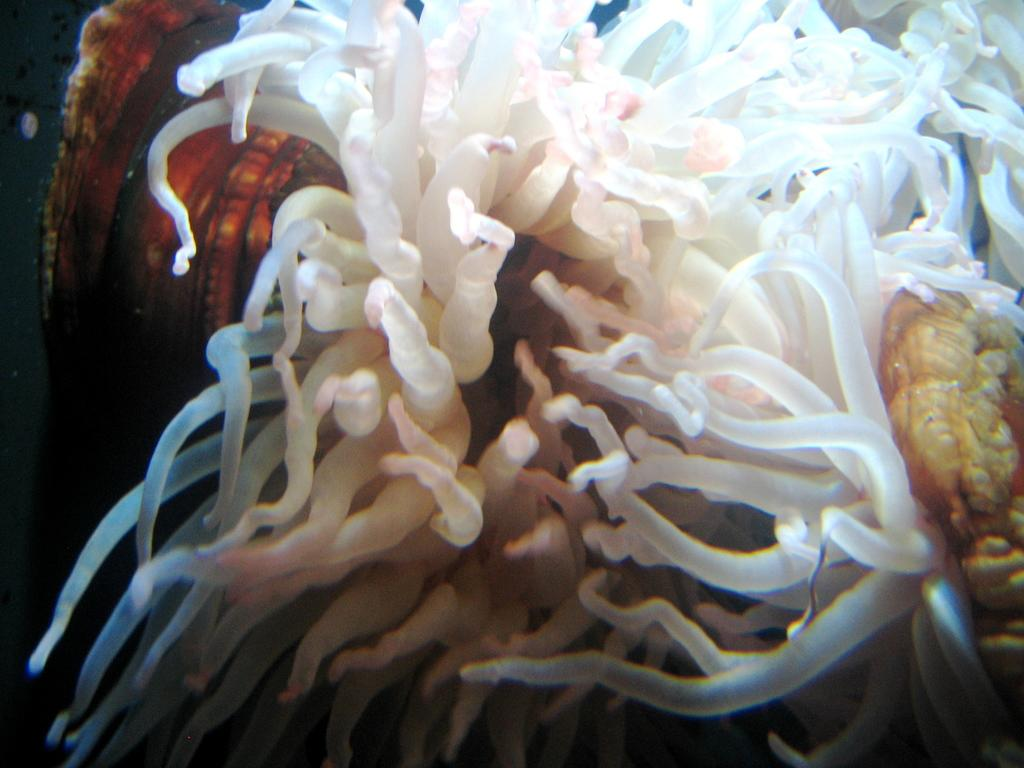What type of plants can be seen in the image? There are underwater plants in the image. Can you describe the environment in which the plants are located? The plants are located underwater. What might be the purpose of these underwater plants? The underwater plants may provide habitat or food for aquatic animals. What type of fruit can be seen hanging from the underwater plants in the image? There is no fruit visible in the image; it only features underwater plants. 